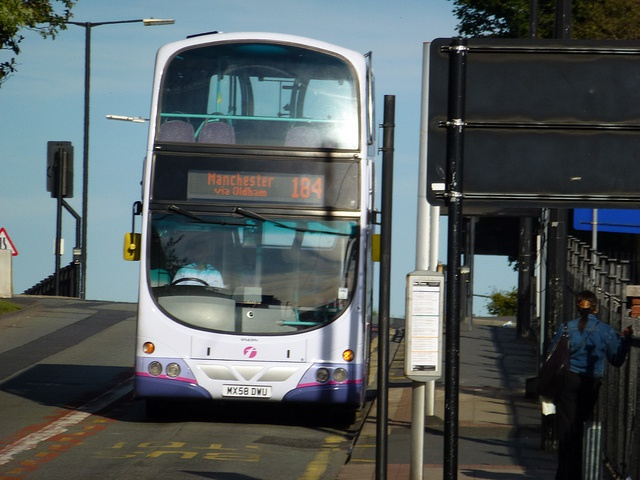Describe the objects in this image and their specific colors. I can see bus in black, gray, lightgray, and darkgray tones, people in black, navy, blue, and maroon tones, handbag in black, gray, and darkblue tones, people in black, purple, lightblue, teal, and gray tones, and traffic light in black, darkblue, and blue tones in this image. 